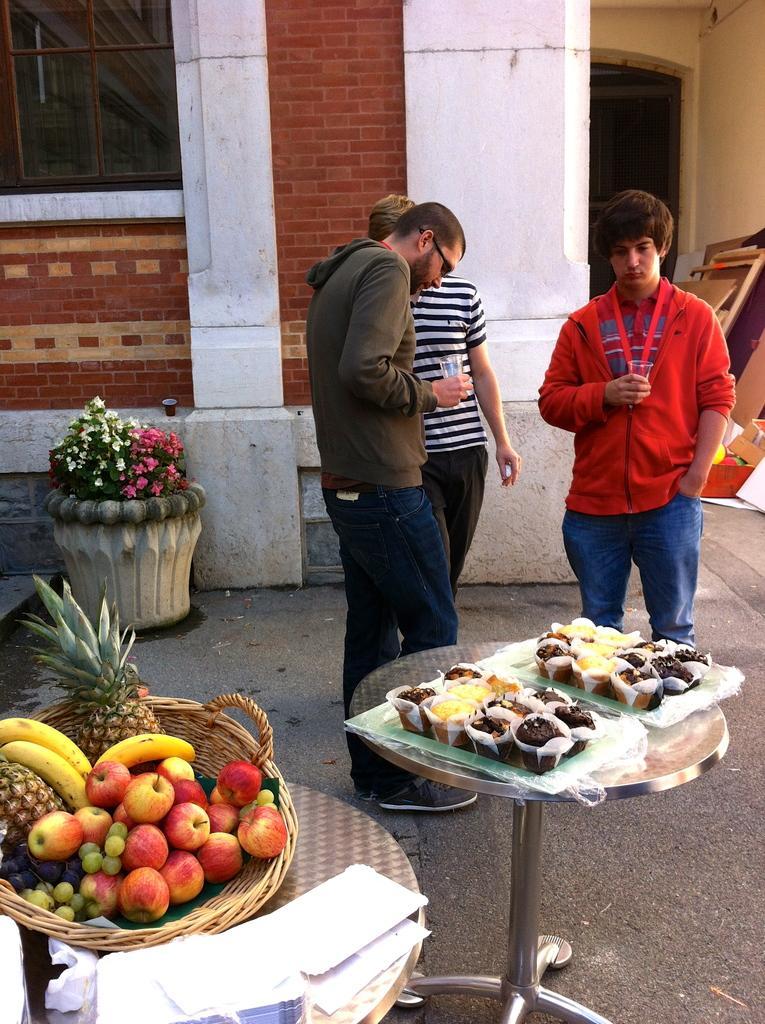Can you describe this image briefly? In this image, we can see three people are standing. Two are holding glasses. Here we can see tables. On top of that, we can see some food, eatable things. Here we can see some objects. Background we can see brick wall, glass windows, door, some objects and flower plant with pot on the path. 